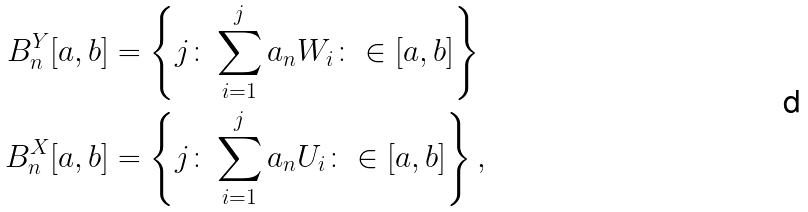Convert formula to latex. <formula><loc_0><loc_0><loc_500><loc_500>B _ { n } ^ { Y } [ a , b ] & = \left \{ j \colon \sum _ { i = 1 } ^ { j } a _ { n } W _ { i } \colon \in [ a , b ] \right \} \\ B _ { n } ^ { X } [ a , b ] & = \left \{ j \colon \sum _ { i = 1 } ^ { j } a _ { n } U _ { i } \colon \in [ a , b ] \right \} ,</formula> 